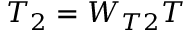<formula> <loc_0><loc_0><loc_500><loc_500>T _ { 2 } = W _ { T 2 } T</formula> 